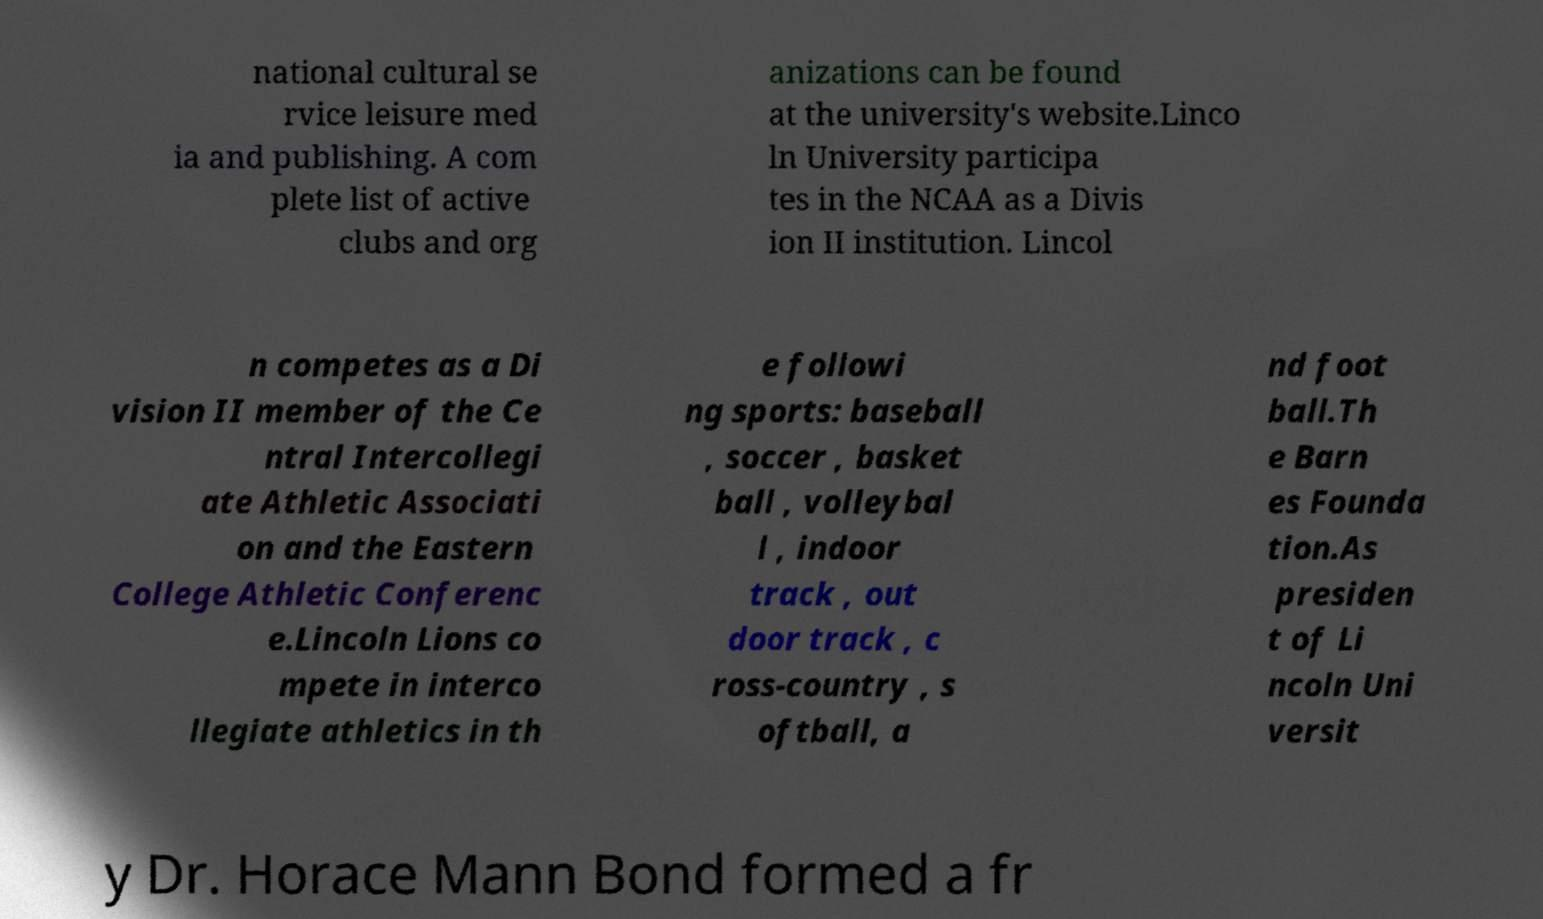For documentation purposes, I need the text within this image transcribed. Could you provide that? national cultural se rvice leisure med ia and publishing. A com plete list of active clubs and org anizations can be found at the university's website.Linco ln University participa tes in the NCAA as a Divis ion II institution. Lincol n competes as a Di vision II member of the Ce ntral Intercollegi ate Athletic Associati on and the Eastern College Athletic Conferenc e.Lincoln Lions co mpete in interco llegiate athletics in th e followi ng sports: baseball , soccer , basket ball , volleybal l , indoor track , out door track , c ross-country , s oftball, a nd foot ball.Th e Barn es Founda tion.As presiden t of Li ncoln Uni versit y Dr. Horace Mann Bond formed a fr 